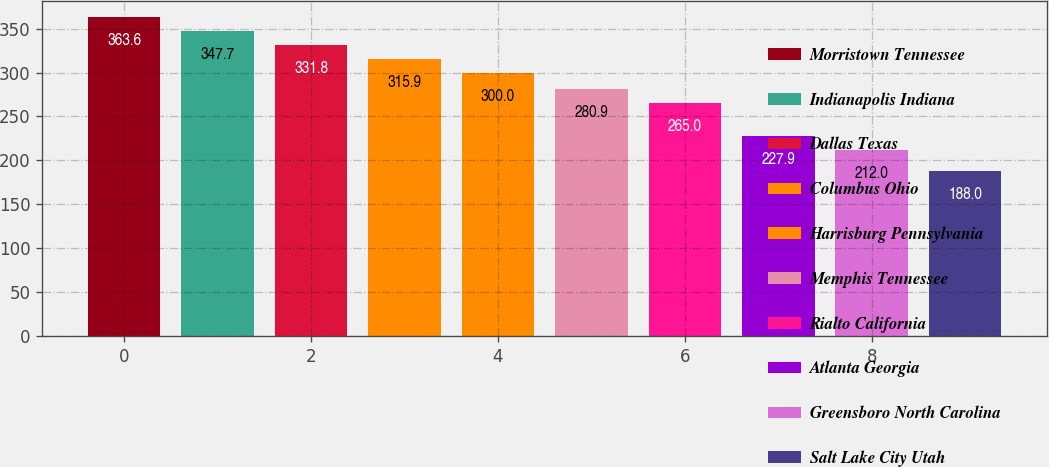<chart> <loc_0><loc_0><loc_500><loc_500><bar_chart><fcel>Morristown Tennessee<fcel>Indianapolis Indiana<fcel>Dallas Texas<fcel>Columbus Ohio<fcel>Harrisburg Pennsylvania<fcel>Memphis Tennessee<fcel>Rialto California<fcel>Atlanta Georgia<fcel>Greensboro North Carolina<fcel>Salt Lake City Utah<nl><fcel>363.6<fcel>347.7<fcel>331.8<fcel>315.9<fcel>300<fcel>280.9<fcel>265<fcel>227.9<fcel>212<fcel>188<nl></chart> 